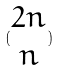<formula> <loc_0><loc_0><loc_500><loc_500>( \begin{matrix} 2 n \\ n \end{matrix} )</formula> 